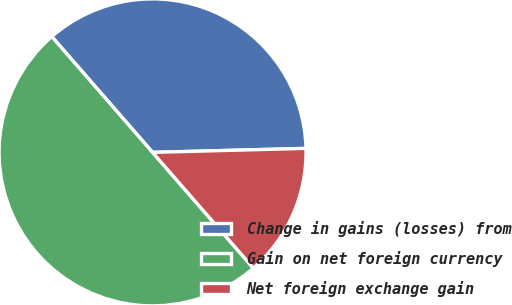Convert chart. <chart><loc_0><loc_0><loc_500><loc_500><pie_chart><fcel>Change in gains (losses) from<fcel>Gain on net foreign currency<fcel>Net foreign exchange gain<nl><fcel>35.99%<fcel>50.0%<fcel>14.01%<nl></chart> 